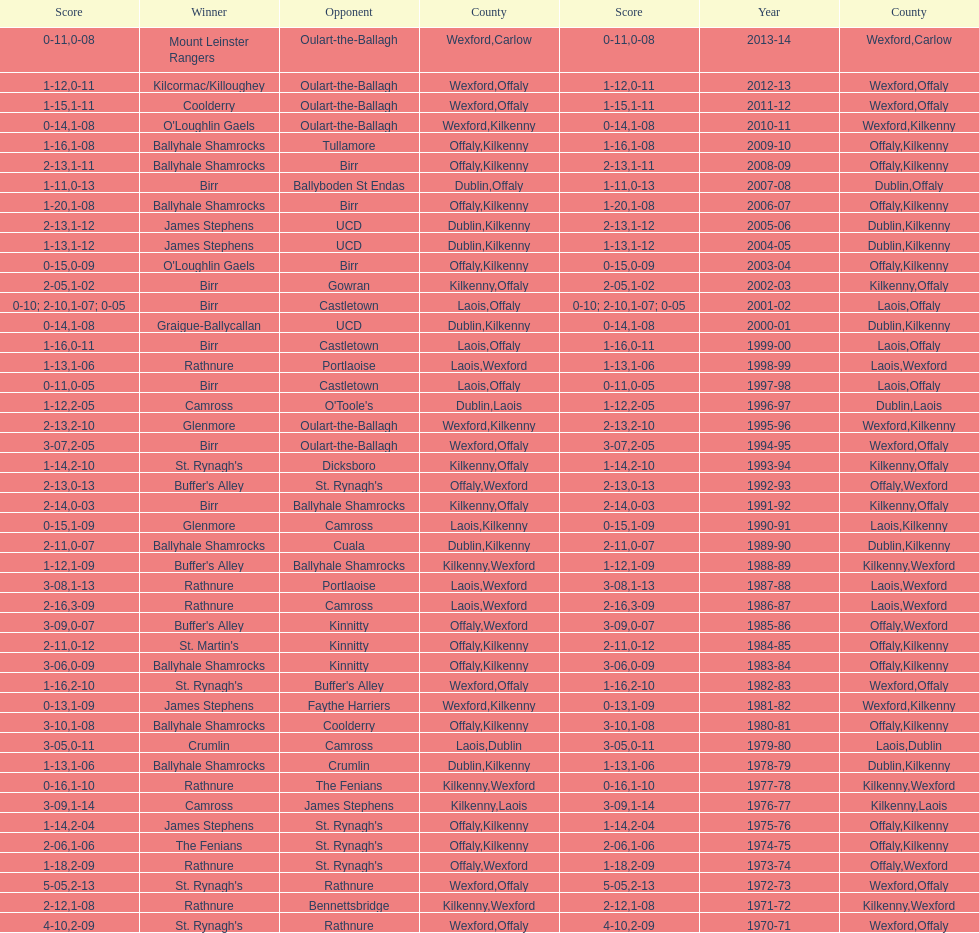What was the last season the leinster senior club hurling championships was won by a score differential of less than 11? 2007-08. 